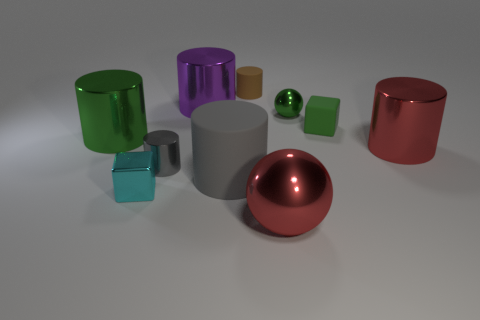Is there a big gray rubber cylinder that is on the right side of the green metallic object that is behind the tiny matte object that is right of the small green metal thing?
Provide a short and direct response. No. How many purple shiny objects are there?
Give a very brief answer. 1. What number of things are big shiny objects that are in front of the gray matte object or rubber cylinders on the left side of the brown rubber cylinder?
Keep it short and to the point. 2. Does the block that is left of the red metallic sphere have the same size as the big red cylinder?
Offer a terse response. No. There is a red object that is the same shape as the purple metallic thing; what is its size?
Provide a succinct answer. Large. There is a red sphere that is the same size as the gray matte cylinder; what is its material?
Provide a short and direct response. Metal. There is a small brown thing that is the same shape as the purple thing; what is its material?
Offer a terse response. Rubber. How many other things are the same size as the green ball?
Keep it short and to the point. 4. There is a cylinder that is the same color as the tiny shiny sphere; what is its size?
Give a very brief answer. Large. What number of cubes are the same color as the large metallic ball?
Your answer should be compact. 0. 